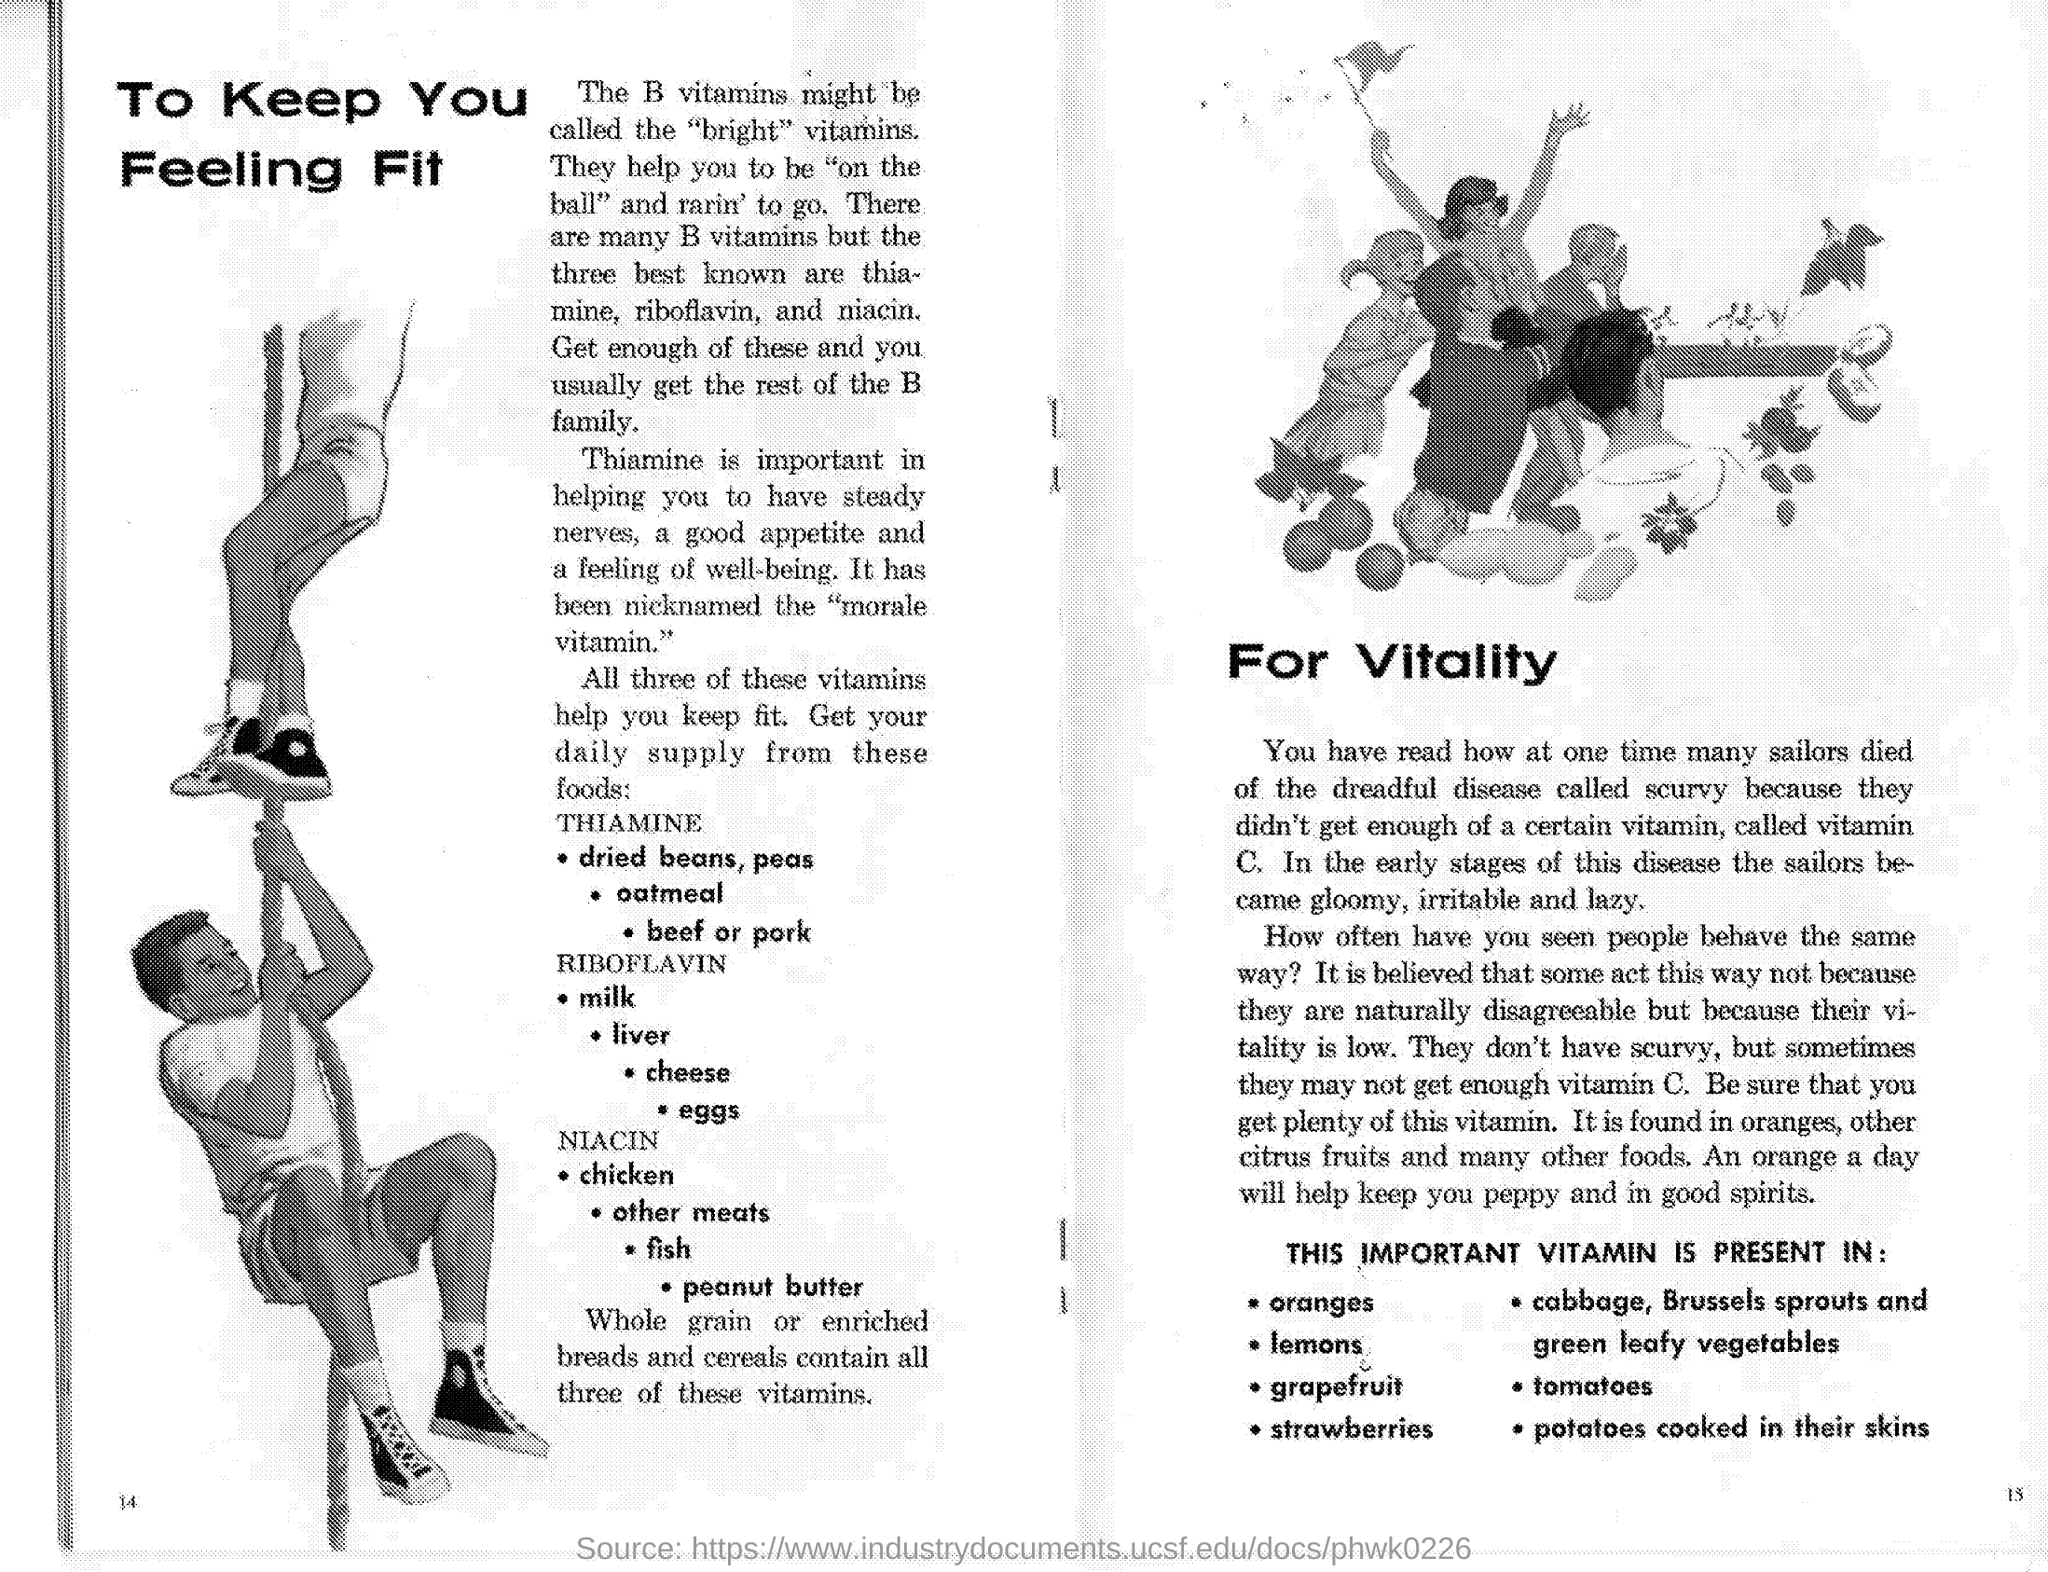What is the nickname given for thiamine ?
Provide a short and direct response. "morale vitamin". 